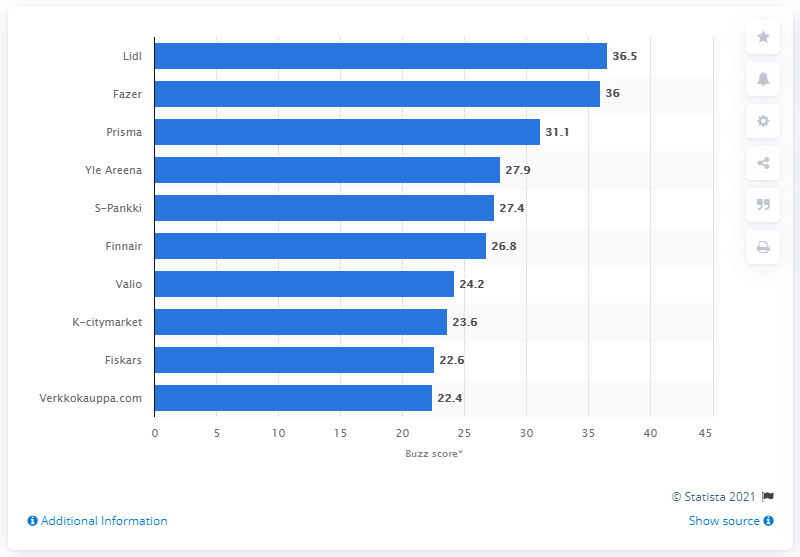Specify some key components in this picture. Fazer, the Finnish food industry corporation, is the name of the company. Valio, a dairy manufacturing company in Finland, ranked fifth in the Buzz score ranking of leading brands in the country. 